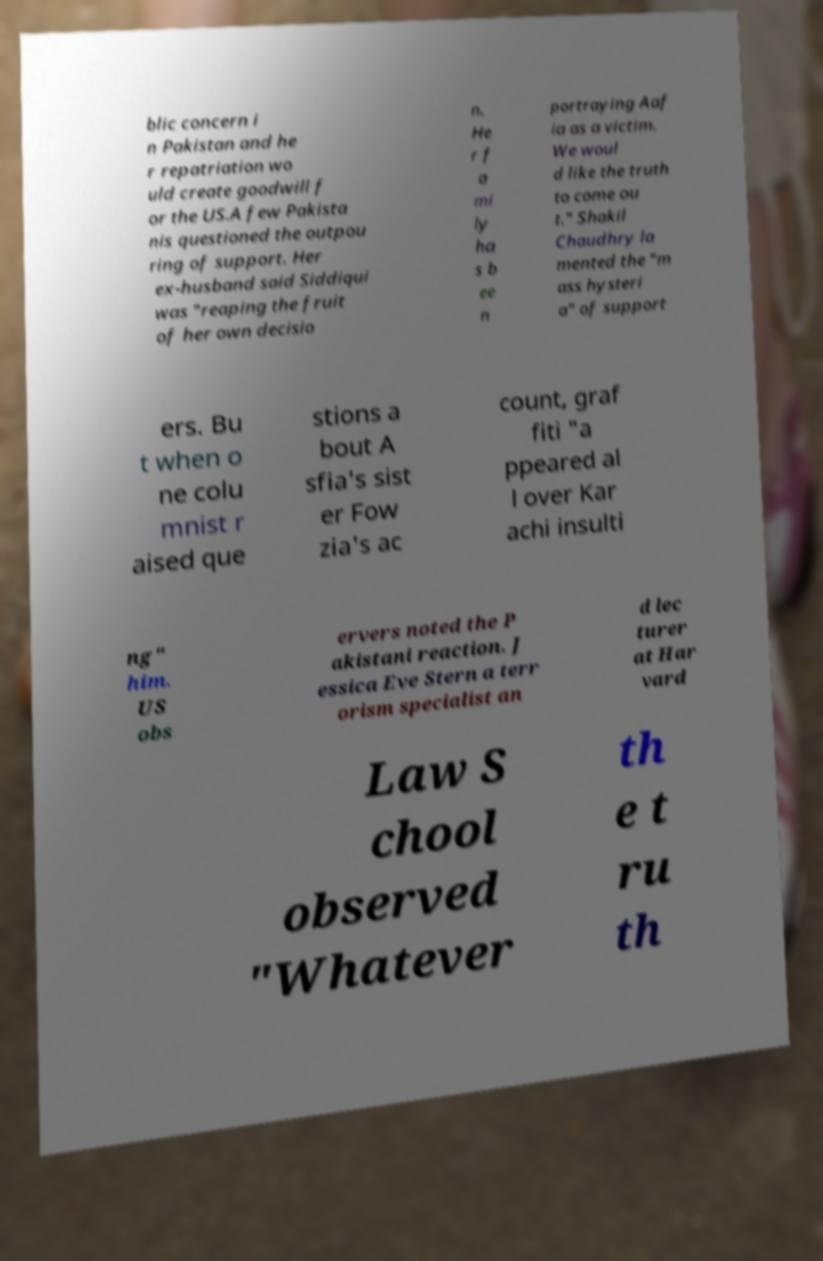Can you accurately transcribe the text from the provided image for me? blic concern i n Pakistan and he r repatriation wo uld create goodwill f or the US.A few Pakista nis questioned the outpou ring of support. Her ex-husband said Siddiqui was "reaping the fruit of her own decisio n. He r f a mi ly ha s b ee n portraying Aaf ia as a victim. We woul d like the truth to come ou t." Shakil Chaudhry la mented the "m ass hysteri a" of support ers. Bu t when o ne colu mnist r aised que stions a bout A sfia's sist er Fow zia's ac count, graf fiti "a ppeared al l over Kar achi insulti ng" him. US obs ervers noted the P akistani reaction. J essica Eve Stern a terr orism specialist an d lec turer at Har vard Law S chool observed "Whatever th e t ru th 